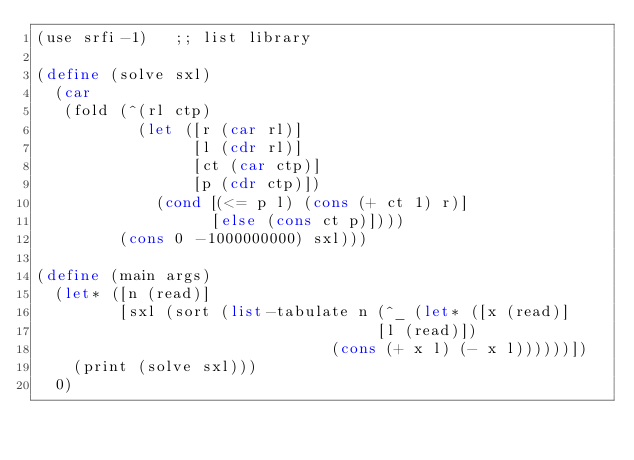<code> <loc_0><loc_0><loc_500><loc_500><_Scheme_>(use srfi-1)   ;; list library

(define (solve sxl)
  (car
   (fold (^(rl ctp)
           (let ([r (car rl)]
                 [l (cdr rl)]
                 [ct (car ctp)]
                 [p (cdr ctp)])
             (cond [(<= p l) (cons (+ ct 1) r)]
                   [else (cons ct p)])))
         (cons 0 -1000000000) sxl)))

(define (main args)
  (let* ([n (read)]
         [sxl (sort (list-tabulate n (^_ (let* ([x (read)]
                                     [l (read)])
                                (cons (+ x l) (- x l))))))])
    (print (solve sxl)))
  0)
</code> 